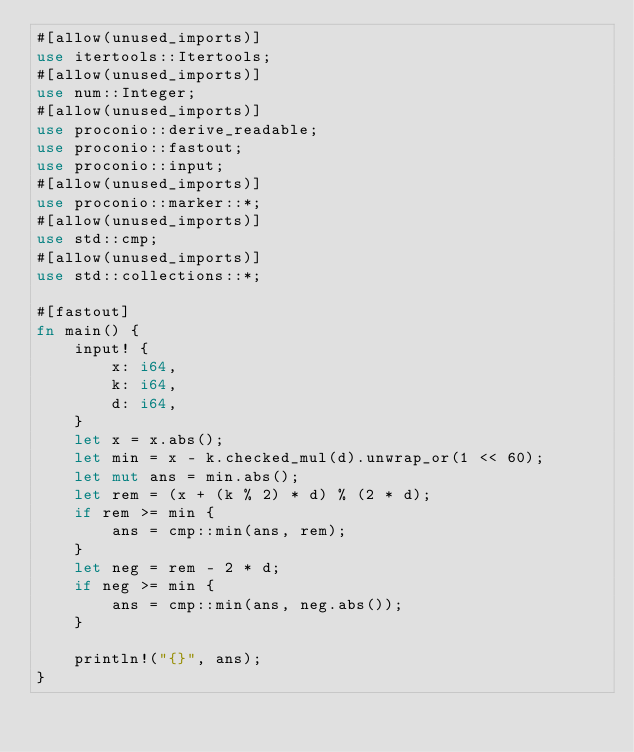Convert code to text. <code><loc_0><loc_0><loc_500><loc_500><_Rust_>#[allow(unused_imports)]
use itertools::Itertools;
#[allow(unused_imports)]
use num::Integer;
#[allow(unused_imports)]
use proconio::derive_readable;
use proconio::fastout;
use proconio::input;
#[allow(unused_imports)]
use proconio::marker::*;
#[allow(unused_imports)]
use std::cmp;
#[allow(unused_imports)]
use std::collections::*;

#[fastout]
fn main() {
    input! {
        x: i64,
        k: i64,
        d: i64,
    }
    let x = x.abs();
    let min = x - k.checked_mul(d).unwrap_or(1 << 60);
    let mut ans = min.abs();
    let rem = (x + (k % 2) * d) % (2 * d);
    if rem >= min {
        ans = cmp::min(ans, rem);
    }
    let neg = rem - 2 * d;
    if neg >= min {
        ans = cmp::min(ans, neg.abs());
    }

    println!("{}", ans);
}
</code> 